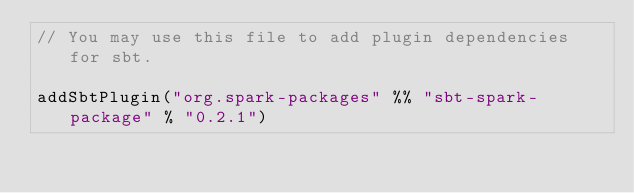<code> <loc_0><loc_0><loc_500><loc_500><_Scala_>// You may use this file to add plugin dependencies for sbt.

addSbtPlugin("org.spark-packages" %% "sbt-spark-package" % "0.2.1")
</code> 